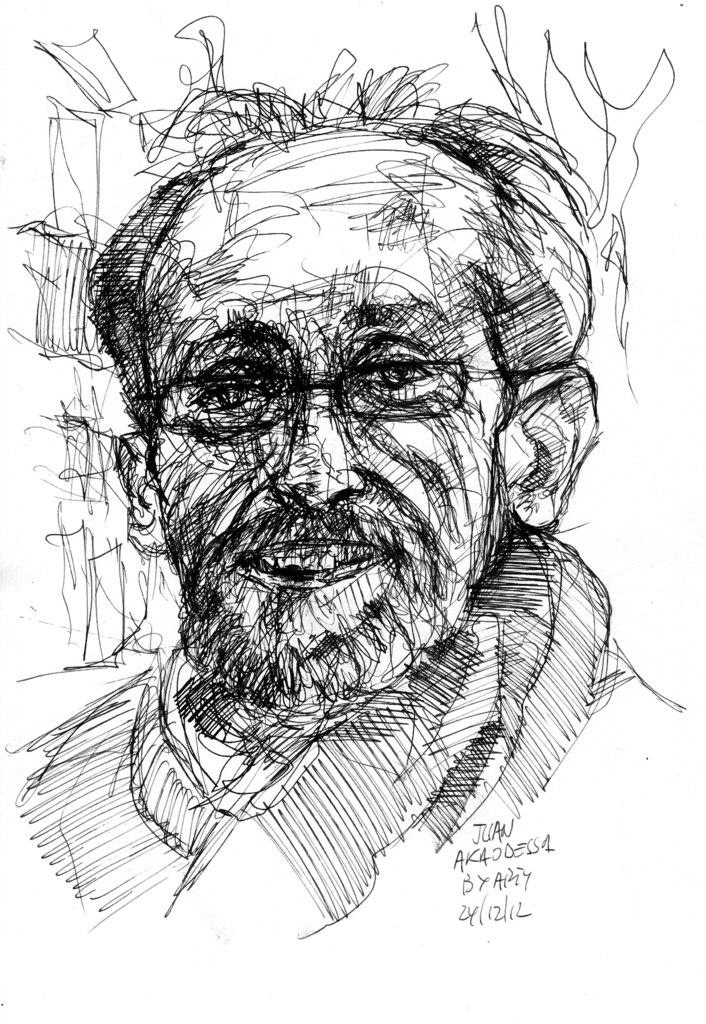What is depicted in the image? There is a drawing of a man in the image. What else can be seen in the image besides the drawing of the man? There is text in the image. What color is the background of the image? The background of the image is white. How many eggs are present in the image? There are no eggs present in the image; it features a drawing of a man and text on a white background. 